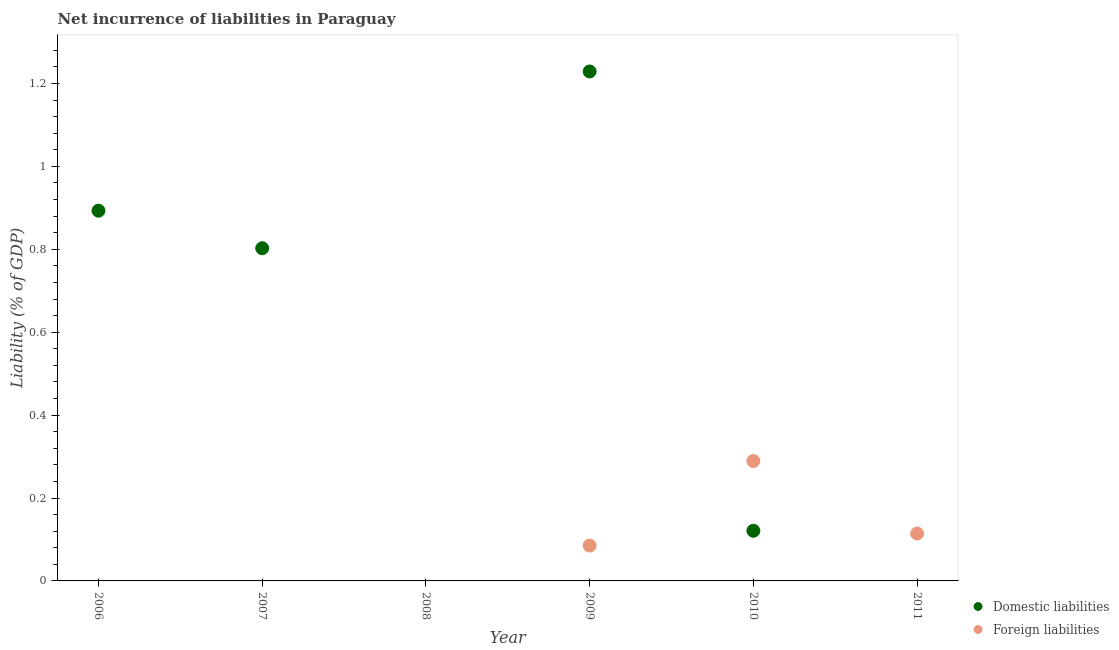Is the number of dotlines equal to the number of legend labels?
Provide a short and direct response. No. What is the incurrence of domestic liabilities in 2010?
Make the answer very short. 0.12. Across all years, what is the maximum incurrence of foreign liabilities?
Offer a terse response. 0.29. What is the total incurrence of foreign liabilities in the graph?
Offer a very short reply. 0.49. What is the difference between the incurrence of domestic liabilities in 2006 and that in 2010?
Offer a terse response. 0.77. What is the difference between the incurrence of domestic liabilities in 2011 and the incurrence of foreign liabilities in 2006?
Make the answer very short. 0. What is the average incurrence of foreign liabilities per year?
Your response must be concise. 0.08. In the year 2009, what is the difference between the incurrence of foreign liabilities and incurrence of domestic liabilities?
Offer a terse response. -1.14. What is the ratio of the incurrence of foreign liabilities in 2010 to that in 2011?
Make the answer very short. 2.53. What is the difference between the highest and the second highest incurrence of foreign liabilities?
Ensure brevity in your answer.  0.17. What is the difference between the highest and the lowest incurrence of foreign liabilities?
Offer a very short reply. 0.29. Is the incurrence of foreign liabilities strictly greater than the incurrence of domestic liabilities over the years?
Make the answer very short. No. Is the incurrence of domestic liabilities strictly less than the incurrence of foreign liabilities over the years?
Ensure brevity in your answer.  No. What is the difference between two consecutive major ticks on the Y-axis?
Offer a very short reply. 0.2. Where does the legend appear in the graph?
Ensure brevity in your answer.  Bottom right. How are the legend labels stacked?
Your response must be concise. Vertical. What is the title of the graph?
Your answer should be very brief. Net incurrence of liabilities in Paraguay. What is the label or title of the Y-axis?
Your answer should be compact. Liability (% of GDP). What is the Liability (% of GDP) of Domestic liabilities in 2006?
Ensure brevity in your answer.  0.89. What is the Liability (% of GDP) of Domestic liabilities in 2007?
Your response must be concise. 0.8. What is the Liability (% of GDP) in Foreign liabilities in 2007?
Make the answer very short. 0. What is the Liability (% of GDP) in Foreign liabilities in 2008?
Provide a succinct answer. 0. What is the Liability (% of GDP) of Domestic liabilities in 2009?
Keep it short and to the point. 1.23. What is the Liability (% of GDP) in Foreign liabilities in 2009?
Your response must be concise. 0.09. What is the Liability (% of GDP) of Domestic liabilities in 2010?
Ensure brevity in your answer.  0.12. What is the Liability (% of GDP) of Foreign liabilities in 2010?
Your answer should be very brief. 0.29. What is the Liability (% of GDP) in Foreign liabilities in 2011?
Make the answer very short. 0.11. Across all years, what is the maximum Liability (% of GDP) of Domestic liabilities?
Offer a terse response. 1.23. Across all years, what is the maximum Liability (% of GDP) in Foreign liabilities?
Provide a succinct answer. 0.29. Across all years, what is the minimum Liability (% of GDP) in Foreign liabilities?
Offer a terse response. 0. What is the total Liability (% of GDP) in Domestic liabilities in the graph?
Your answer should be compact. 3.05. What is the total Liability (% of GDP) in Foreign liabilities in the graph?
Make the answer very short. 0.49. What is the difference between the Liability (% of GDP) in Domestic liabilities in 2006 and that in 2007?
Provide a succinct answer. 0.09. What is the difference between the Liability (% of GDP) in Domestic liabilities in 2006 and that in 2009?
Offer a terse response. -0.34. What is the difference between the Liability (% of GDP) in Domestic liabilities in 2006 and that in 2010?
Provide a short and direct response. 0.77. What is the difference between the Liability (% of GDP) of Domestic liabilities in 2007 and that in 2009?
Ensure brevity in your answer.  -0.43. What is the difference between the Liability (% of GDP) of Domestic liabilities in 2007 and that in 2010?
Ensure brevity in your answer.  0.68. What is the difference between the Liability (% of GDP) in Domestic liabilities in 2009 and that in 2010?
Your answer should be very brief. 1.11. What is the difference between the Liability (% of GDP) of Foreign liabilities in 2009 and that in 2010?
Provide a short and direct response. -0.2. What is the difference between the Liability (% of GDP) of Foreign liabilities in 2009 and that in 2011?
Offer a terse response. -0.03. What is the difference between the Liability (% of GDP) of Foreign liabilities in 2010 and that in 2011?
Provide a short and direct response. 0.17. What is the difference between the Liability (% of GDP) of Domestic liabilities in 2006 and the Liability (% of GDP) of Foreign liabilities in 2009?
Your answer should be very brief. 0.81. What is the difference between the Liability (% of GDP) in Domestic liabilities in 2006 and the Liability (% of GDP) in Foreign liabilities in 2010?
Your answer should be very brief. 0.6. What is the difference between the Liability (% of GDP) of Domestic liabilities in 2006 and the Liability (% of GDP) of Foreign liabilities in 2011?
Offer a terse response. 0.78. What is the difference between the Liability (% of GDP) of Domestic liabilities in 2007 and the Liability (% of GDP) of Foreign liabilities in 2009?
Your response must be concise. 0.72. What is the difference between the Liability (% of GDP) in Domestic liabilities in 2007 and the Liability (% of GDP) in Foreign liabilities in 2010?
Give a very brief answer. 0.51. What is the difference between the Liability (% of GDP) of Domestic liabilities in 2007 and the Liability (% of GDP) of Foreign liabilities in 2011?
Your answer should be compact. 0.69. What is the difference between the Liability (% of GDP) of Domestic liabilities in 2009 and the Liability (% of GDP) of Foreign liabilities in 2010?
Ensure brevity in your answer.  0.94. What is the difference between the Liability (% of GDP) in Domestic liabilities in 2009 and the Liability (% of GDP) in Foreign liabilities in 2011?
Provide a short and direct response. 1.11. What is the difference between the Liability (% of GDP) of Domestic liabilities in 2010 and the Liability (% of GDP) of Foreign liabilities in 2011?
Provide a succinct answer. 0.01. What is the average Liability (% of GDP) in Domestic liabilities per year?
Ensure brevity in your answer.  0.51. What is the average Liability (% of GDP) in Foreign liabilities per year?
Your answer should be very brief. 0.08. In the year 2009, what is the difference between the Liability (% of GDP) of Domestic liabilities and Liability (% of GDP) of Foreign liabilities?
Your answer should be very brief. 1.14. In the year 2010, what is the difference between the Liability (% of GDP) of Domestic liabilities and Liability (% of GDP) of Foreign liabilities?
Your answer should be compact. -0.17. What is the ratio of the Liability (% of GDP) in Domestic liabilities in 2006 to that in 2007?
Make the answer very short. 1.11. What is the ratio of the Liability (% of GDP) of Domestic liabilities in 2006 to that in 2009?
Your answer should be very brief. 0.73. What is the ratio of the Liability (% of GDP) in Domestic liabilities in 2006 to that in 2010?
Ensure brevity in your answer.  7.38. What is the ratio of the Liability (% of GDP) in Domestic liabilities in 2007 to that in 2009?
Offer a very short reply. 0.65. What is the ratio of the Liability (% of GDP) in Domestic liabilities in 2007 to that in 2010?
Ensure brevity in your answer.  6.63. What is the ratio of the Liability (% of GDP) of Domestic liabilities in 2009 to that in 2010?
Give a very brief answer. 10.16. What is the ratio of the Liability (% of GDP) of Foreign liabilities in 2009 to that in 2010?
Provide a short and direct response. 0.29. What is the ratio of the Liability (% of GDP) in Foreign liabilities in 2009 to that in 2011?
Your answer should be compact. 0.75. What is the ratio of the Liability (% of GDP) in Foreign liabilities in 2010 to that in 2011?
Give a very brief answer. 2.53. What is the difference between the highest and the second highest Liability (% of GDP) in Domestic liabilities?
Make the answer very short. 0.34. What is the difference between the highest and the second highest Liability (% of GDP) of Foreign liabilities?
Provide a succinct answer. 0.17. What is the difference between the highest and the lowest Liability (% of GDP) of Domestic liabilities?
Offer a very short reply. 1.23. What is the difference between the highest and the lowest Liability (% of GDP) of Foreign liabilities?
Your answer should be very brief. 0.29. 